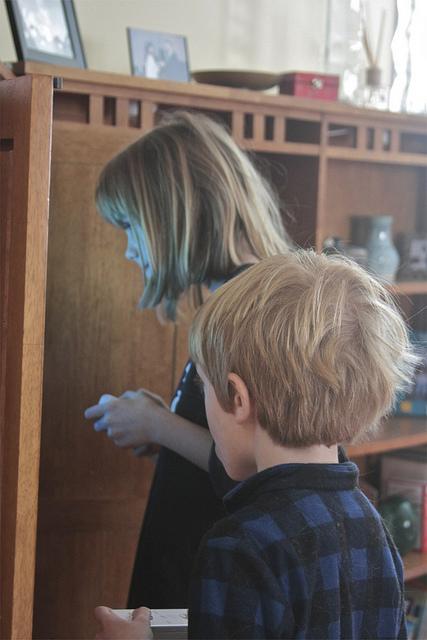What are the kids looking at?
Concise answer only. Tv. Is the boy wearing plaid?
Be succinct. Yes. What color is the box on top of the shelves?
Give a very brief answer. Red. Did he just do something bad?
Answer briefly. No. 